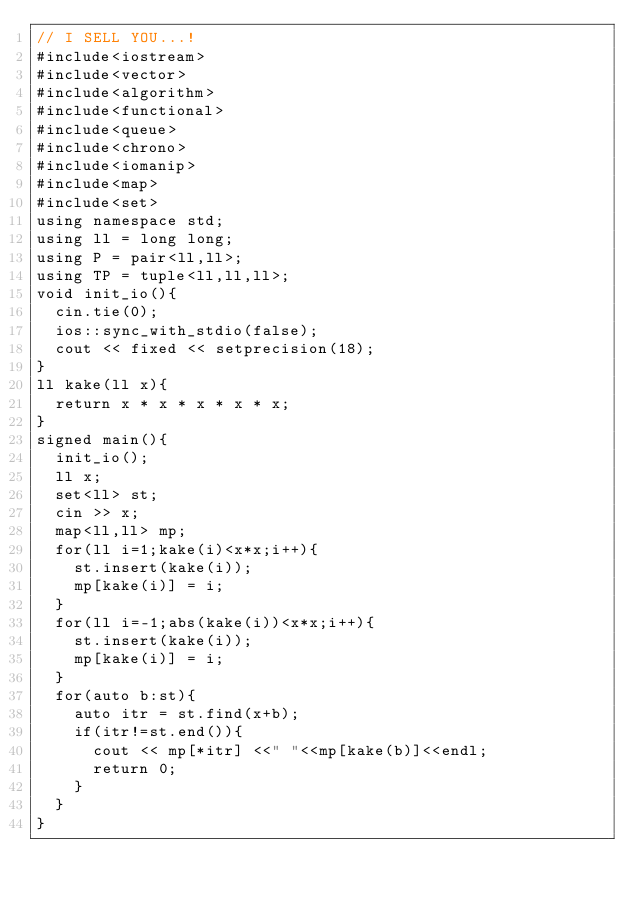<code> <loc_0><loc_0><loc_500><loc_500><_C++_>// I SELL YOU...! 
#include<iostream>
#include<vector>
#include<algorithm>
#include<functional>
#include<queue>
#include<chrono>
#include<iomanip>
#include<map>
#include<set>
using namespace std;
using ll = long long;
using P = pair<ll,ll>;
using TP = tuple<ll,ll,ll>;
void init_io(){
  cin.tie(0);
  ios::sync_with_stdio(false);
  cout << fixed << setprecision(18);
}
ll kake(ll x){
  return x * x * x * x * x;
}
signed main(){
  init_io();
  ll x;
  set<ll> st;
  cin >> x;
  map<ll,ll> mp;
  for(ll i=1;kake(i)<x*x;i++){
    st.insert(kake(i));
    mp[kake(i)] = i;
  }
  for(ll i=-1;abs(kake(i))<x*x;i++){
    st.insert(kake(i));
    mp[kake(i)] = i;
  }
  for(auto b:st){
    auto itr = st.find(x+b);
    if(itr!=st.end()){
      cout << mp[*itr] <<" "<<mp[kake(b)]<<endl;
      return 0;
    }
  }
}
</code> 